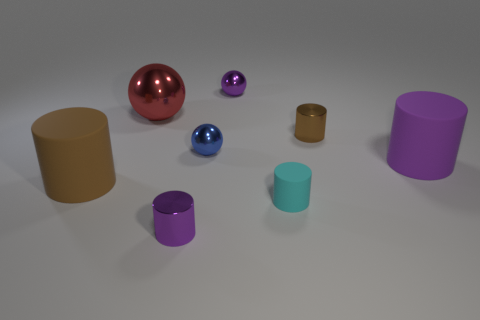What number of tiny metal things are the same shape as the tiny matte thing?
Ensure brevity in your answer.  2. What is the material of the brown thing that is the same size as the blue object?
Your answer should be very brief. Metal. There is a purple cylinder that is in front of the small cyan matte cylinder to the right of the small purple metallic thing that is behind the small cyan rubber cylinder; what is its size?
Ensure brevity in your answer.  Small. Does the big cylinder that is on the right side of the red ball have the same color as the metallic cylinder that is in front of the big purple object?
Offer a very short reply. Yes. How many brown things are either small metallic things or shiny spheres?
Provide a succinct answer. 1. What number of metallic objects are the same size as the purple shiny cylinder?
Your response must be concise. 3. Do the object in front of the tiny rubber cylinder and the purple ball have the same material?
Give a very brief answer. Yes. Are there any big things to the left of the small purple object in front of the cyan matte cylinder?
Offer a very short reply. Yes. What is the material of the big brown thing that is the same shape as the small cyan rubber thing?
Give a very brief answer. Rubber. Are there more matte objects in front of the purple rubber cylinder than metallic cylinders that are behind the brown matte object?
Give a very brief answer. Yes. 